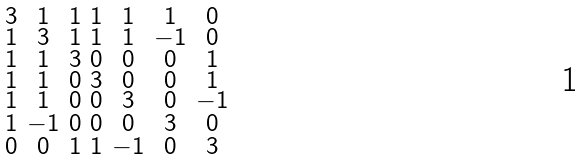Convert formula to latex. <formula><loc_0><loc_0><loc_500><loc_500>\begin{smallmatrix} 3 & 1 & 1 & 1 & 1 & 1 & 0 \\ 1 & 3 & 1 & 1 & 1 & - 1 & 0 \\ 1 & 1 & 3 & 0 & 0 & 0 & 1 \\ 1 & 1 & 0 & 3 & 0 & 0 & 1 \\ 1 & 1 & 0 & 0 & 3 & 0 & - 1 \\ 1 & - 1 & 0 & 0 & 0 & 3 & 0 \\ 0 & 0 & 1 & 1 & - 1 & 0 & 3 \end{smallmatrix}</formula> 